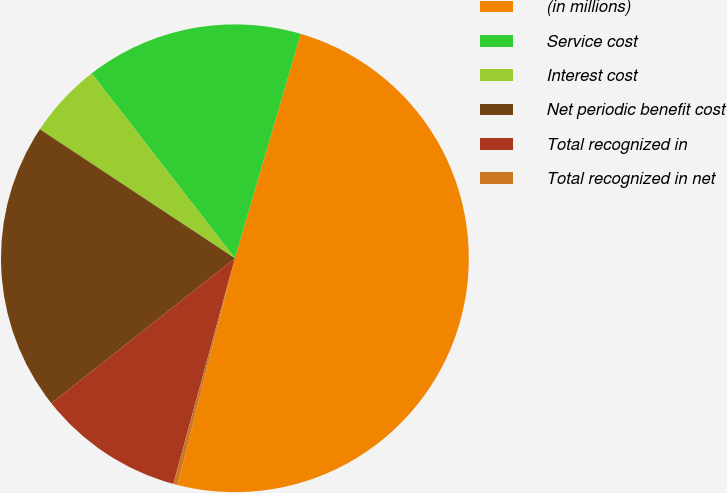Convert chart. <chart><loc_0><loc_0><loc_500><loc_500><pie_chart><fcel>(in millions)<fcel>Service cost<fcel>Interest cost<fcel>Net periodic benefit cost<fcel>Total recognized in<fcel>Total recognized in net<nl><fcel>49.41%<fcel>15.03%<fcel>5.21%<fcel>19.94%<fcel>10.12%<fcel>0.29%<nl></chart> 